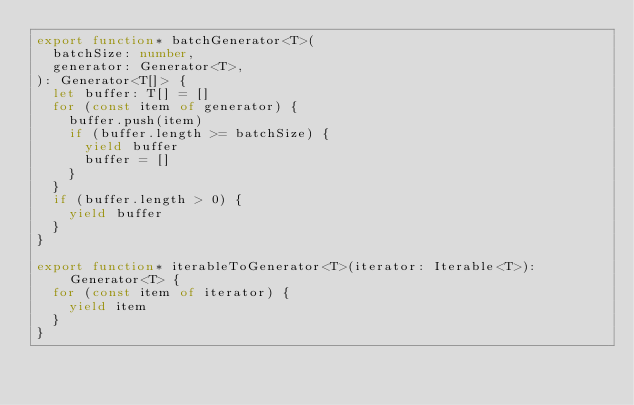<code> <loc_0><loc_0><loc_500><loc_500><_TypeScript_>export function* batchGenerator<T>(
  batchSize: number,
  generator: Generator<T>,
): Generator<T[]> {
  let buffer: T[] = []
  for (const item of generator) {
    buffer.push(item)
    if (buffer.length >= batchSize) {
      yield buffer
      buffer = []
    }
  }
  if (buffer.length > 0) {
    yield buffer
  }
}

export function* iterableToGenerator<T>(iterator: Iterable<T>): Generator<T> {
  for (const item of iterator) {
    yield item
  }
}
</code> 